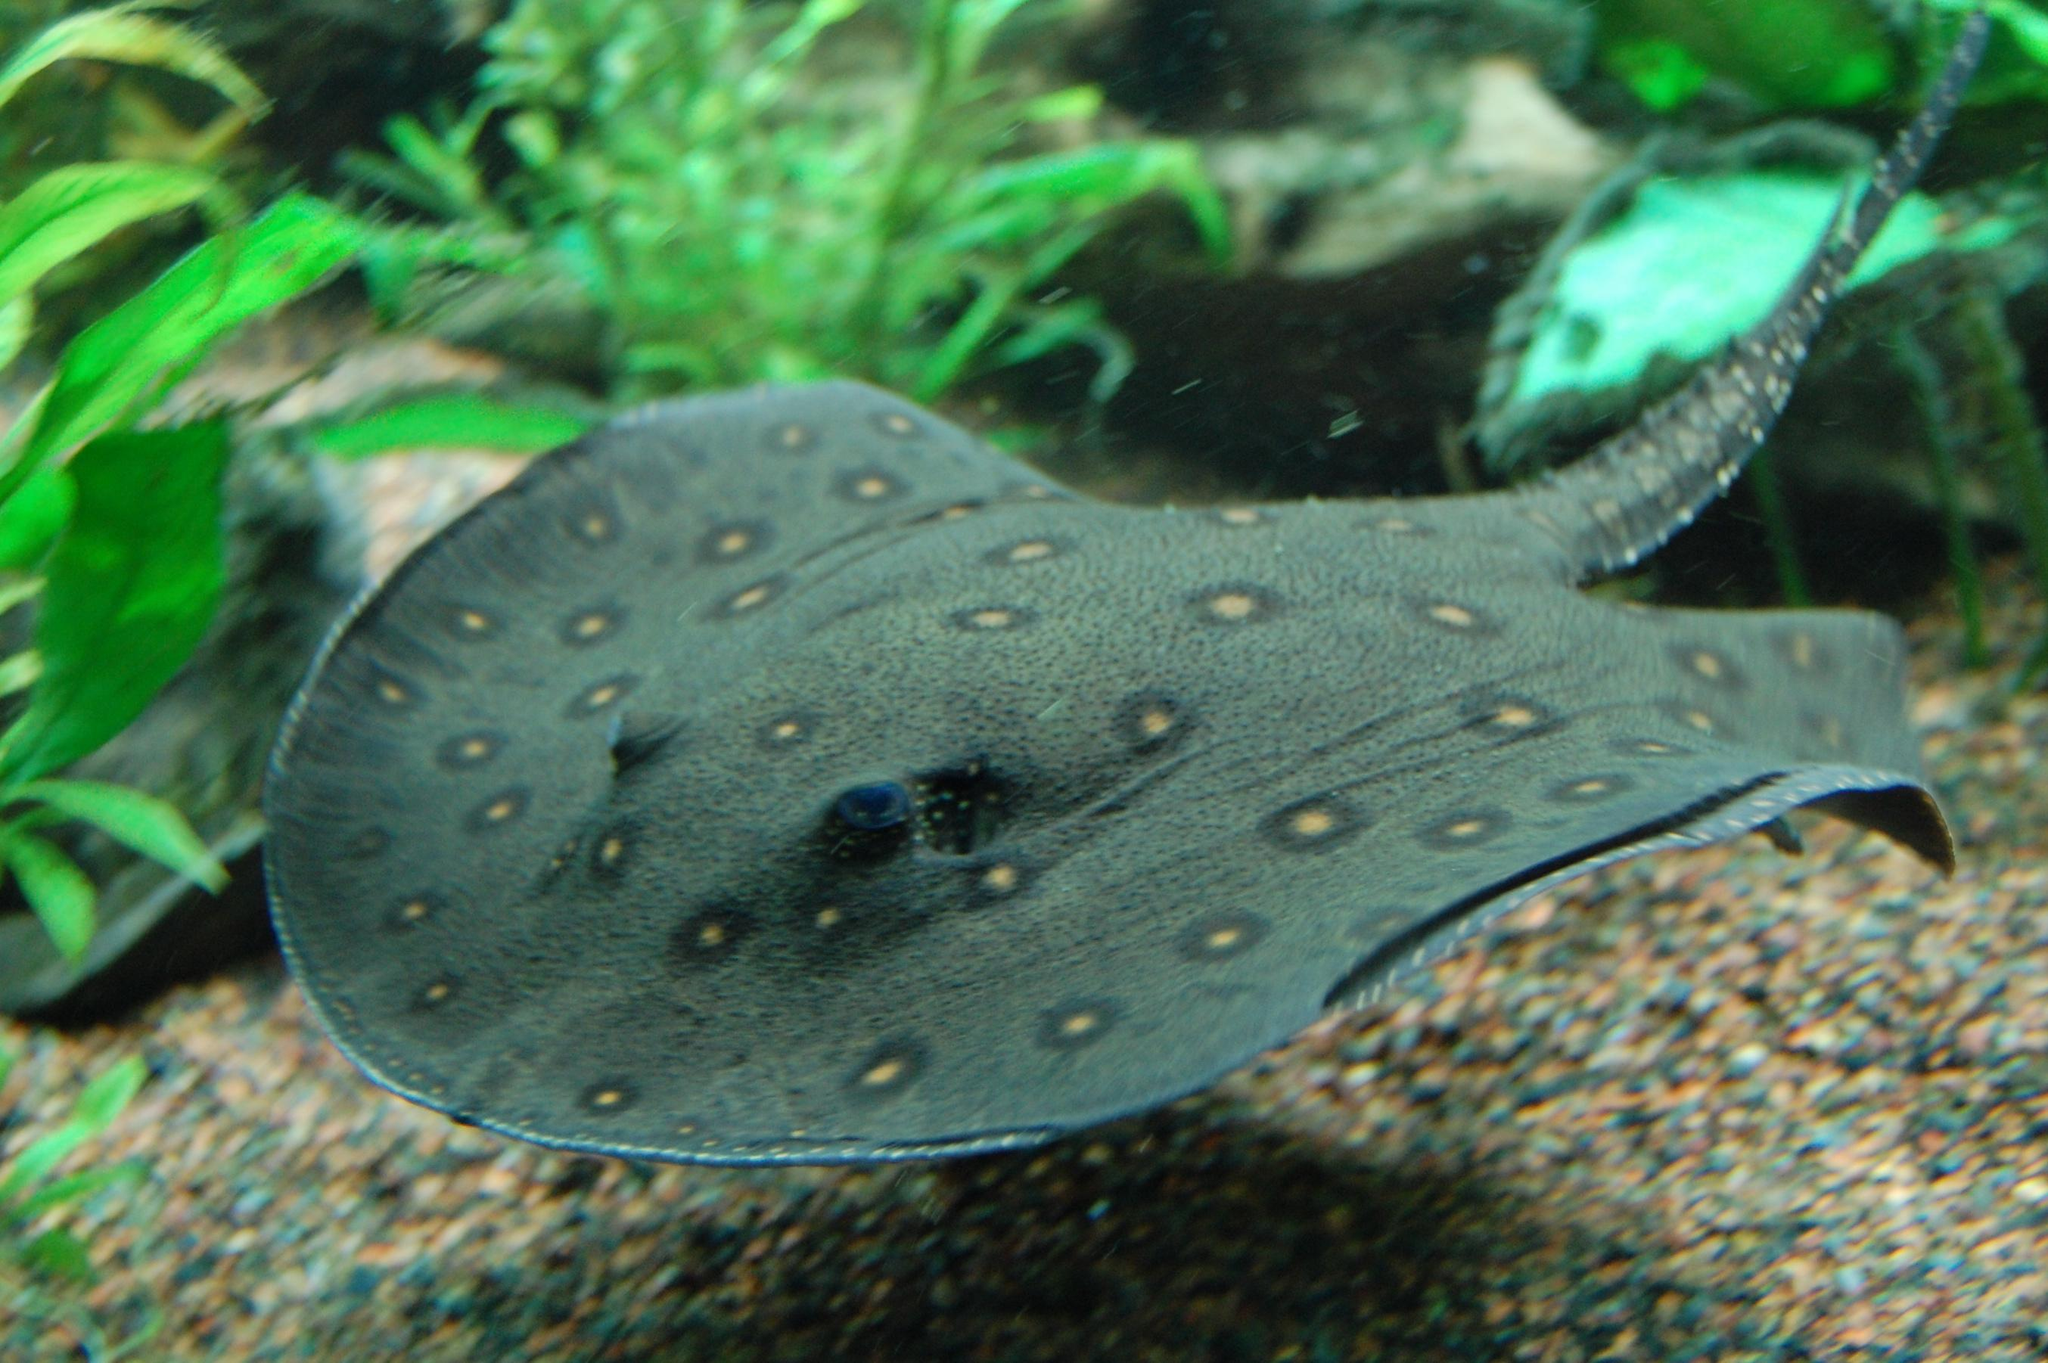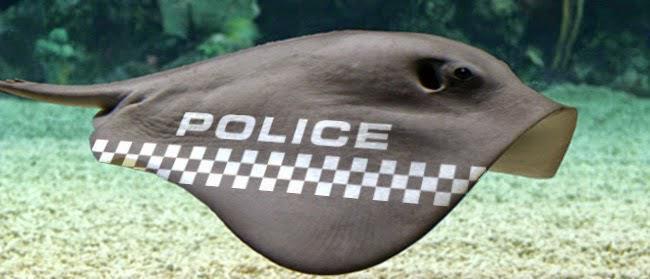The first image is the image on the left, the second image is the image on the right. Considering the images on both sides, is "There is a stingray facing right in the right image." valid? Answer yes or no. Yes. The first image is the image on the left, the second image is the image on the right. Considering the images on both sides, is "The stingrays in each pair are looking in the opposite direction from each other." valid? Answer yes or no. Yes. 